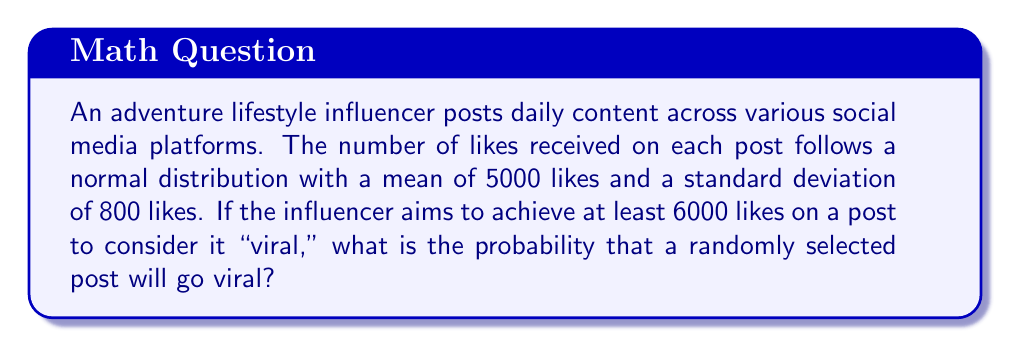Provide a solution to this math problem. To solve this problem, we need to use the properties of the normal distribution and calculate the z-score for the threshold value. Then, we'll use a standard normal table or the z-score to find the probability.

Step 1: Identify the given information
- The distribution of likes is normal
- Mean (μ) = 5000 likes
- Standard deviation (σ) = 800 likes
- Threshold for "viral" = 6000 likes

Step 2: Calculate the z-score for the threshold value
The z-score formula is: $z = \frac{x - μ}{σ}$

Where:
x = threshold value
μ = mean
σ = standard deviation

Plugging in the values:

$z = \frac{6000 - 5000}{800} = \frac{1000}{800} = 1.25$

Step 3: Use the z-score to find the probability
The z-score of 1.25 represents the number of standard deviations the threshold is above the mean. We need to find the probability of a value being greater than this z-score.

Using a standard normal table or calculator, we find that the area to the right of z = 1.25 is approximately 0.1056.

Step 4: Interpret the result
The probability of 0.1056 means that approximately 10.56% of the posts will receive 6000 or more likes, thus going viral.
Answer: 0.1056 or 10.56% 